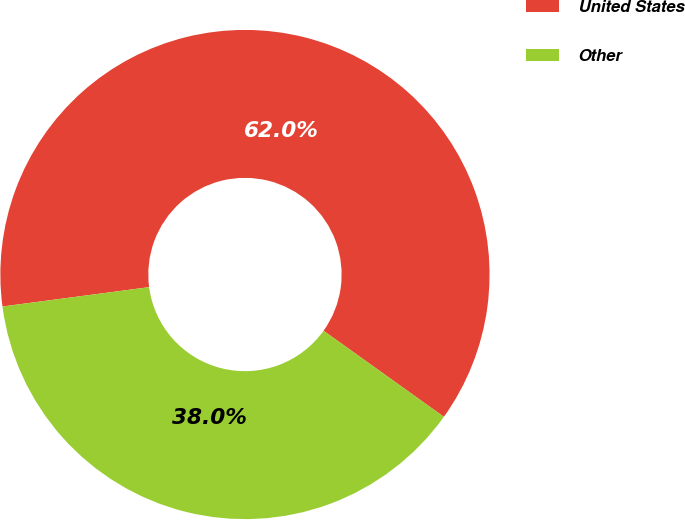Convert chart. <chart><loc_0><loc_0><loc_500><loc_500><pie_chart><fcel>United States<fcel>Other<nl><fcel>61.97%<fcel>38.03%<nl></chart> 